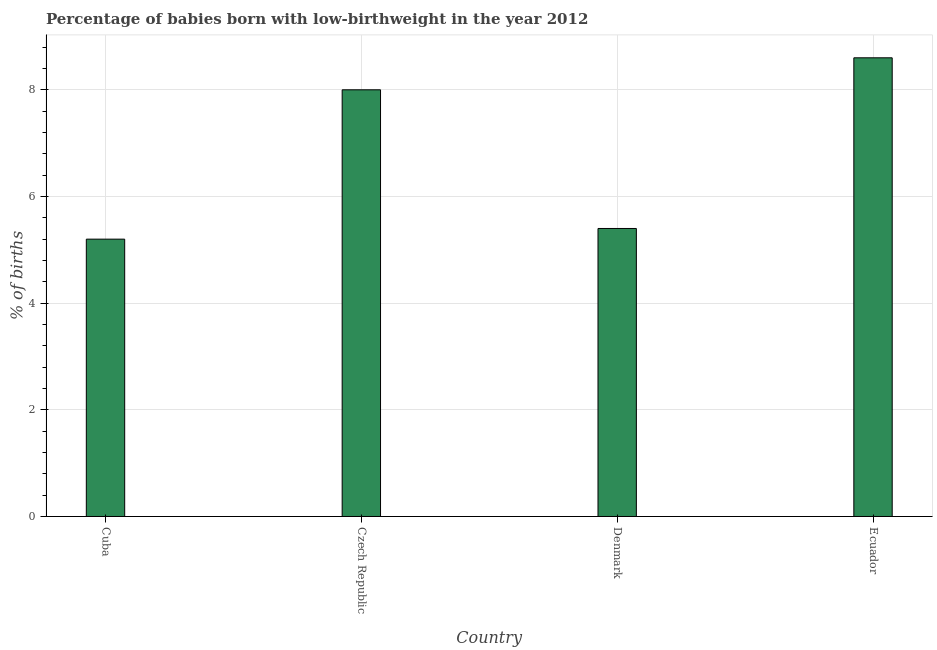Does the graph contain grids?
Make the answer very short. Yes. What is the title of the graph?
Ensure brevity in your answer.  Percentage of babies born with low-birthweight in the year 2012. What is the label or title of the X-axis?
Your response must be concise. Country. What is the label or title of the Y-axis?
Ensure brevity in your answer.  % of births. In which country was the percentage of babies who were born with low-birthweight maximum?
Ensure brevity in your answer.  Ecuador. In which country was the percentage of babies who were born with low-birthweight minimum?
Your answer should be very brief. Cuba. What is the sum of the percentage of babies who were born with low-birthweight?
Provide a short and direct response. 27.2. In how many countries, is the percentage of babies who were born with low-birthweight greater than 1.2 %?
Your response must be concise. 4. What is the ratio of the percentage of babies who were born with low-birthweight in Denmark to that in Ecuador?
Make the answer very short. 0.63. Is the percentage of babies who were born with low-birthweight in Czech Republic less than that in Denmark?
Provide a succinct answer. No. Is the difference between the percentage of babies who were born with low-birthweight in Czech Republic and Denmark greater than the difference between any two countries?
Keep it short and to the point. No. Is the sum of the percentage of babies who were born with low-birthweight in Czech Republic and Denmark greater than the maximum percentage of babies who were born with low-birthweight across all countries?
Provide a short and direct response. Yes. How many bars are there?
Your answer should be compact. 4. Are all the bars in the graph horizontal?
Your answer should be very brief. No. Are the values on the major ticks of Y-axis written in scientific E-notation?
Offer a terse response. No. What is the % of births of Cuba?
Make the answer very short. 5.2. What is the % of births in Ecuador?
Your answer should be compact. 8.6. What is the difference between the % of births in Cuba and Denmark?
Provide a short and direct response. -0.2. What is the difference between the % of births in Cuba and Ecuador?
Your response must be concise. -3.4. What is the difference between the % of births in Denmark and Ecuador?
Ensure brevity in your answer.  -3.2. What is the ratio of the % of births in Cuba to that in Czech Republic?
Provide a succinct answer. 0.65. What is the ratio of the % of births in Cuba to that in Denmark?
Provide a short and direct response. 0.96. What is the ratio of the % of births in Cuba to that in Ecuador?
Offer a terse response. 0.6. What is the ratio of the % of births in Czech Republic to that in Denmark?
Your response must be concise. 1.48. What is the ratio of the % of births in Czech Republic to that in Ecuador?
Keep it short and to the point. 0.93. What is the ratio of the % of births in Denmark to that in Ecuador?
Ensure brevity in your answer.  0.63. 